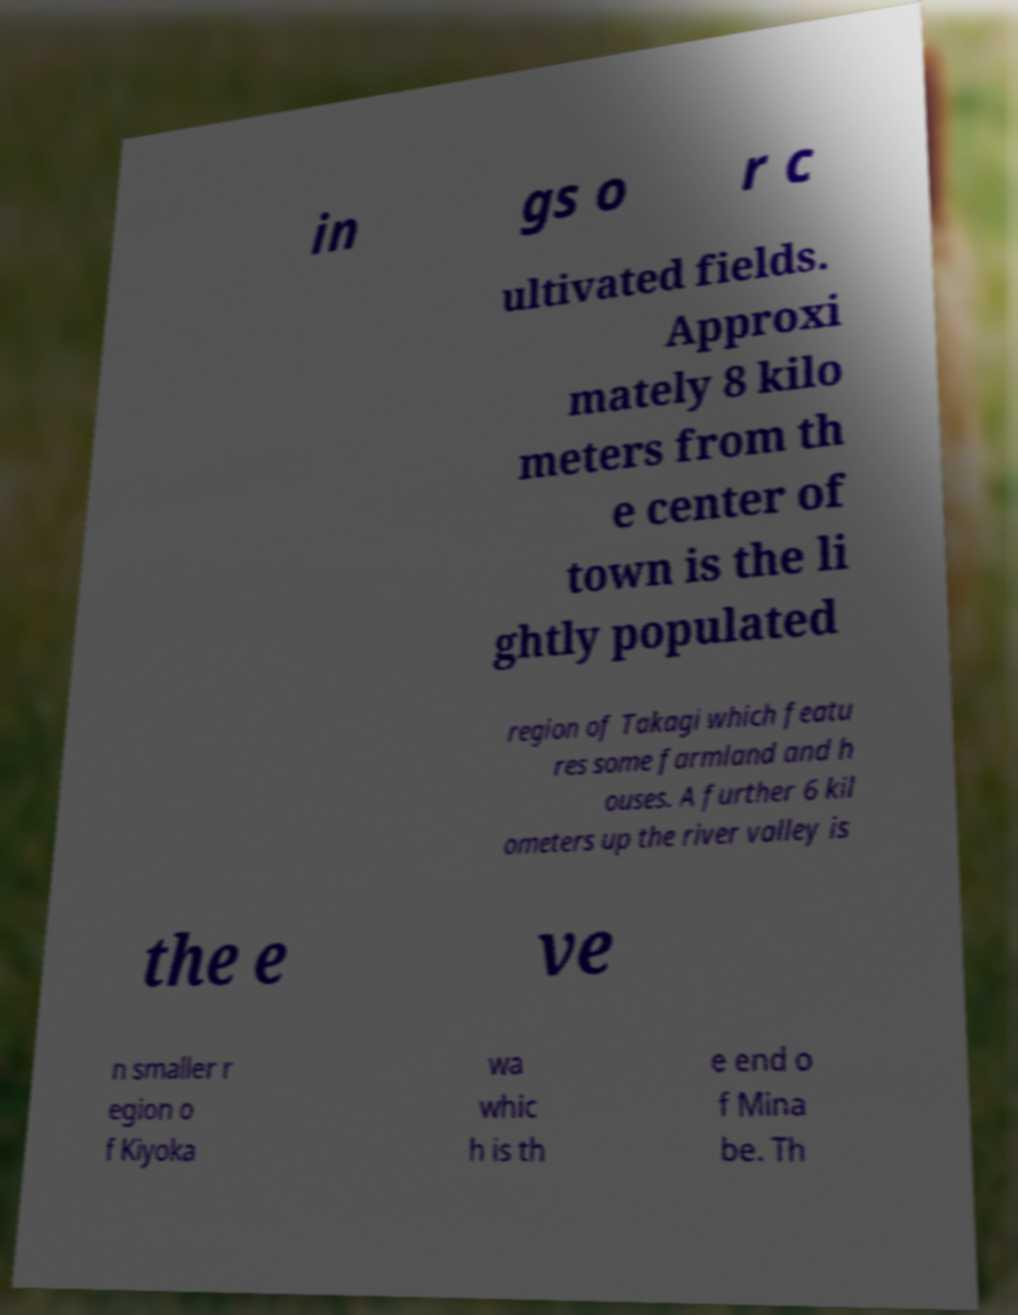What messages or text are displayed in this image? I need them in a readable, typed format. in gs o r c ultivated fields. Approxi mately 8 kilo meters from th e center of town is the li ghtly populated region of Takagi which featu res some farmland and h ouses. A further 6 kil ometers up the river valley is the e ve n smaller r egion o f Kiyoka wa whic h is th e end o f Mina be. Th 